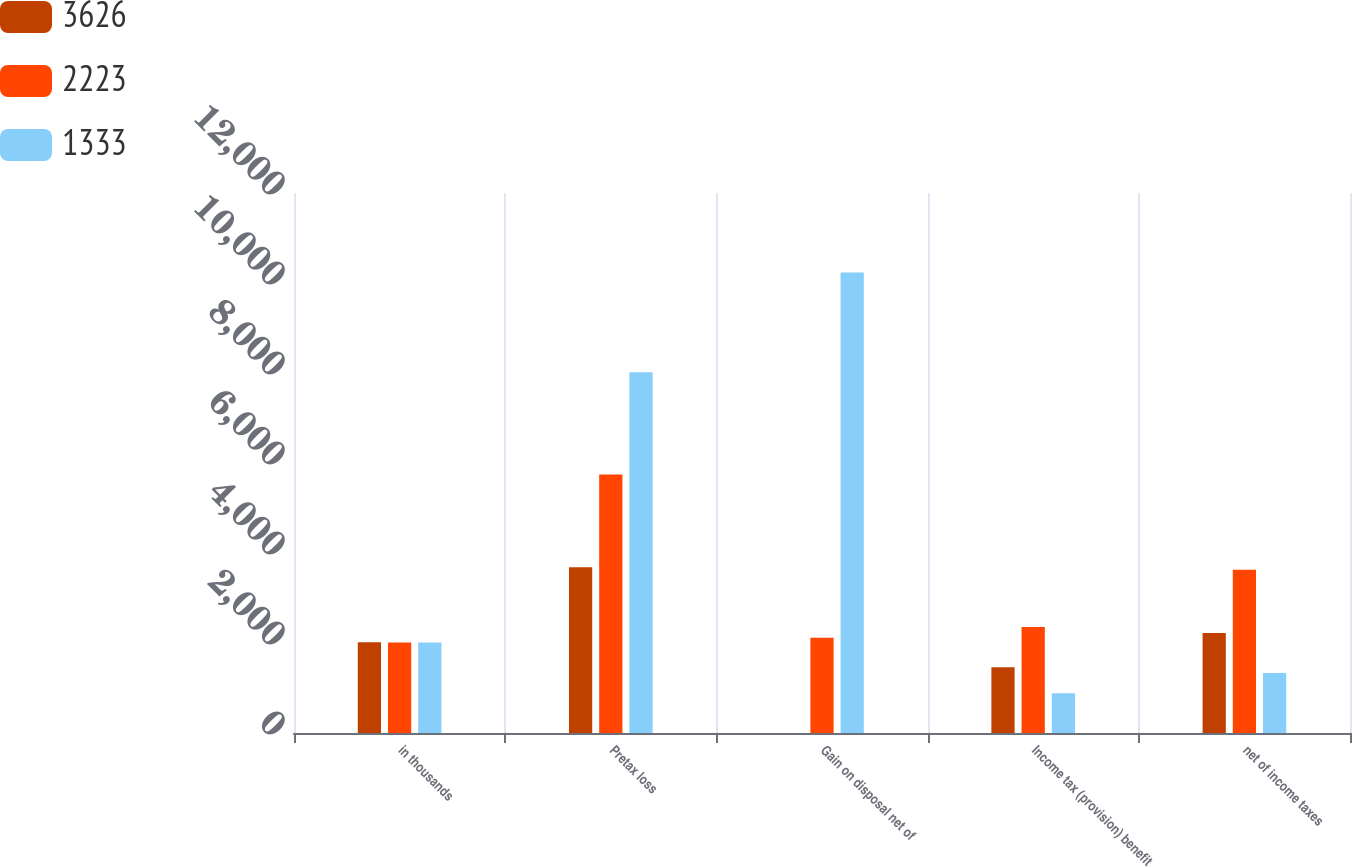Convert chart to OTSL. <chart><loc_0><loc_0><loc_500><loc_500><stacked_bar_chart><ecel><fcel>in thousands<fcel>Pretax loss<fcel>Gain on disposal net of<fcel>Income tax (provision) benefit<fcel>net of income taxes<nl><fcel>3626<fcel>2014<fcel>3683<fcel>0<fcel>1460<fcel>2223<nl><fcel>2223<fcel>2013<fcel>5744<fcel>2118.5<fcel>2358<fcel>3626<nl><fcel>1333<fcel>2012<fcel>8017<fcel>10232<fcel>882<fcel>1333<nl></chart> 